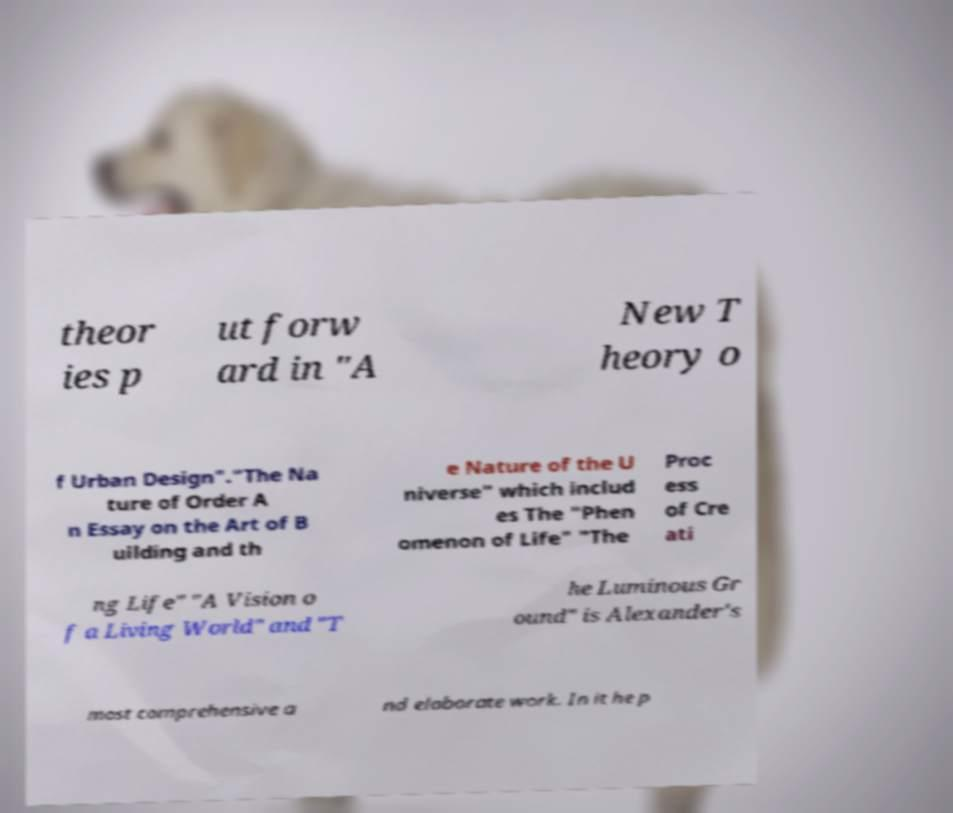For documentation purposes, I need the text within this image transcribed. Could you provide that? theor ies p ut forw ard in "A New T heory o f Urban Design"."The Na ture of Order A n Essay on the Art of B uilding and th e Nature of the U niverse" which includ es The "Phen omenon of Life" "The Proc ess of Cre ati ng Life" "A Vision o f a Living World" and "T he Luminous Gr ound" is Alexander's most comprehensive a nd elaborate work. In it he p 